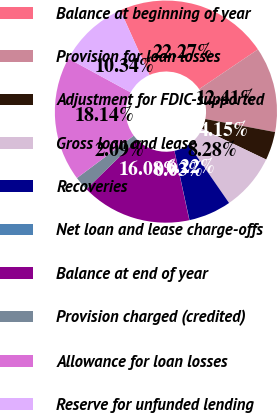<chart> <loc_0><loc_0><loc_500><loc_500><pie_chart><fcel>Balance at beginning of year<fcel>Provision for loan losses<fcel>Adjustment for FDIC-supported<fcel>Gross loan and lease<fcel>Recoveries<fcel>Net loan and lease charge-offs<fcel>Balance at end of year<fcel>Provision charged (credited)<fcel>Allowance for loan losses<fcel>Reserve for unfunded lending<nl><fcel>22.27%<fcel>12.41%<fcel>4.15%<fcel>8.28%<fcel>6.22%<fcel>0.03%<fcel>16.08%<fcel>2.09%<fcel>18.14%<fcel>10.34%<nl></chart> 